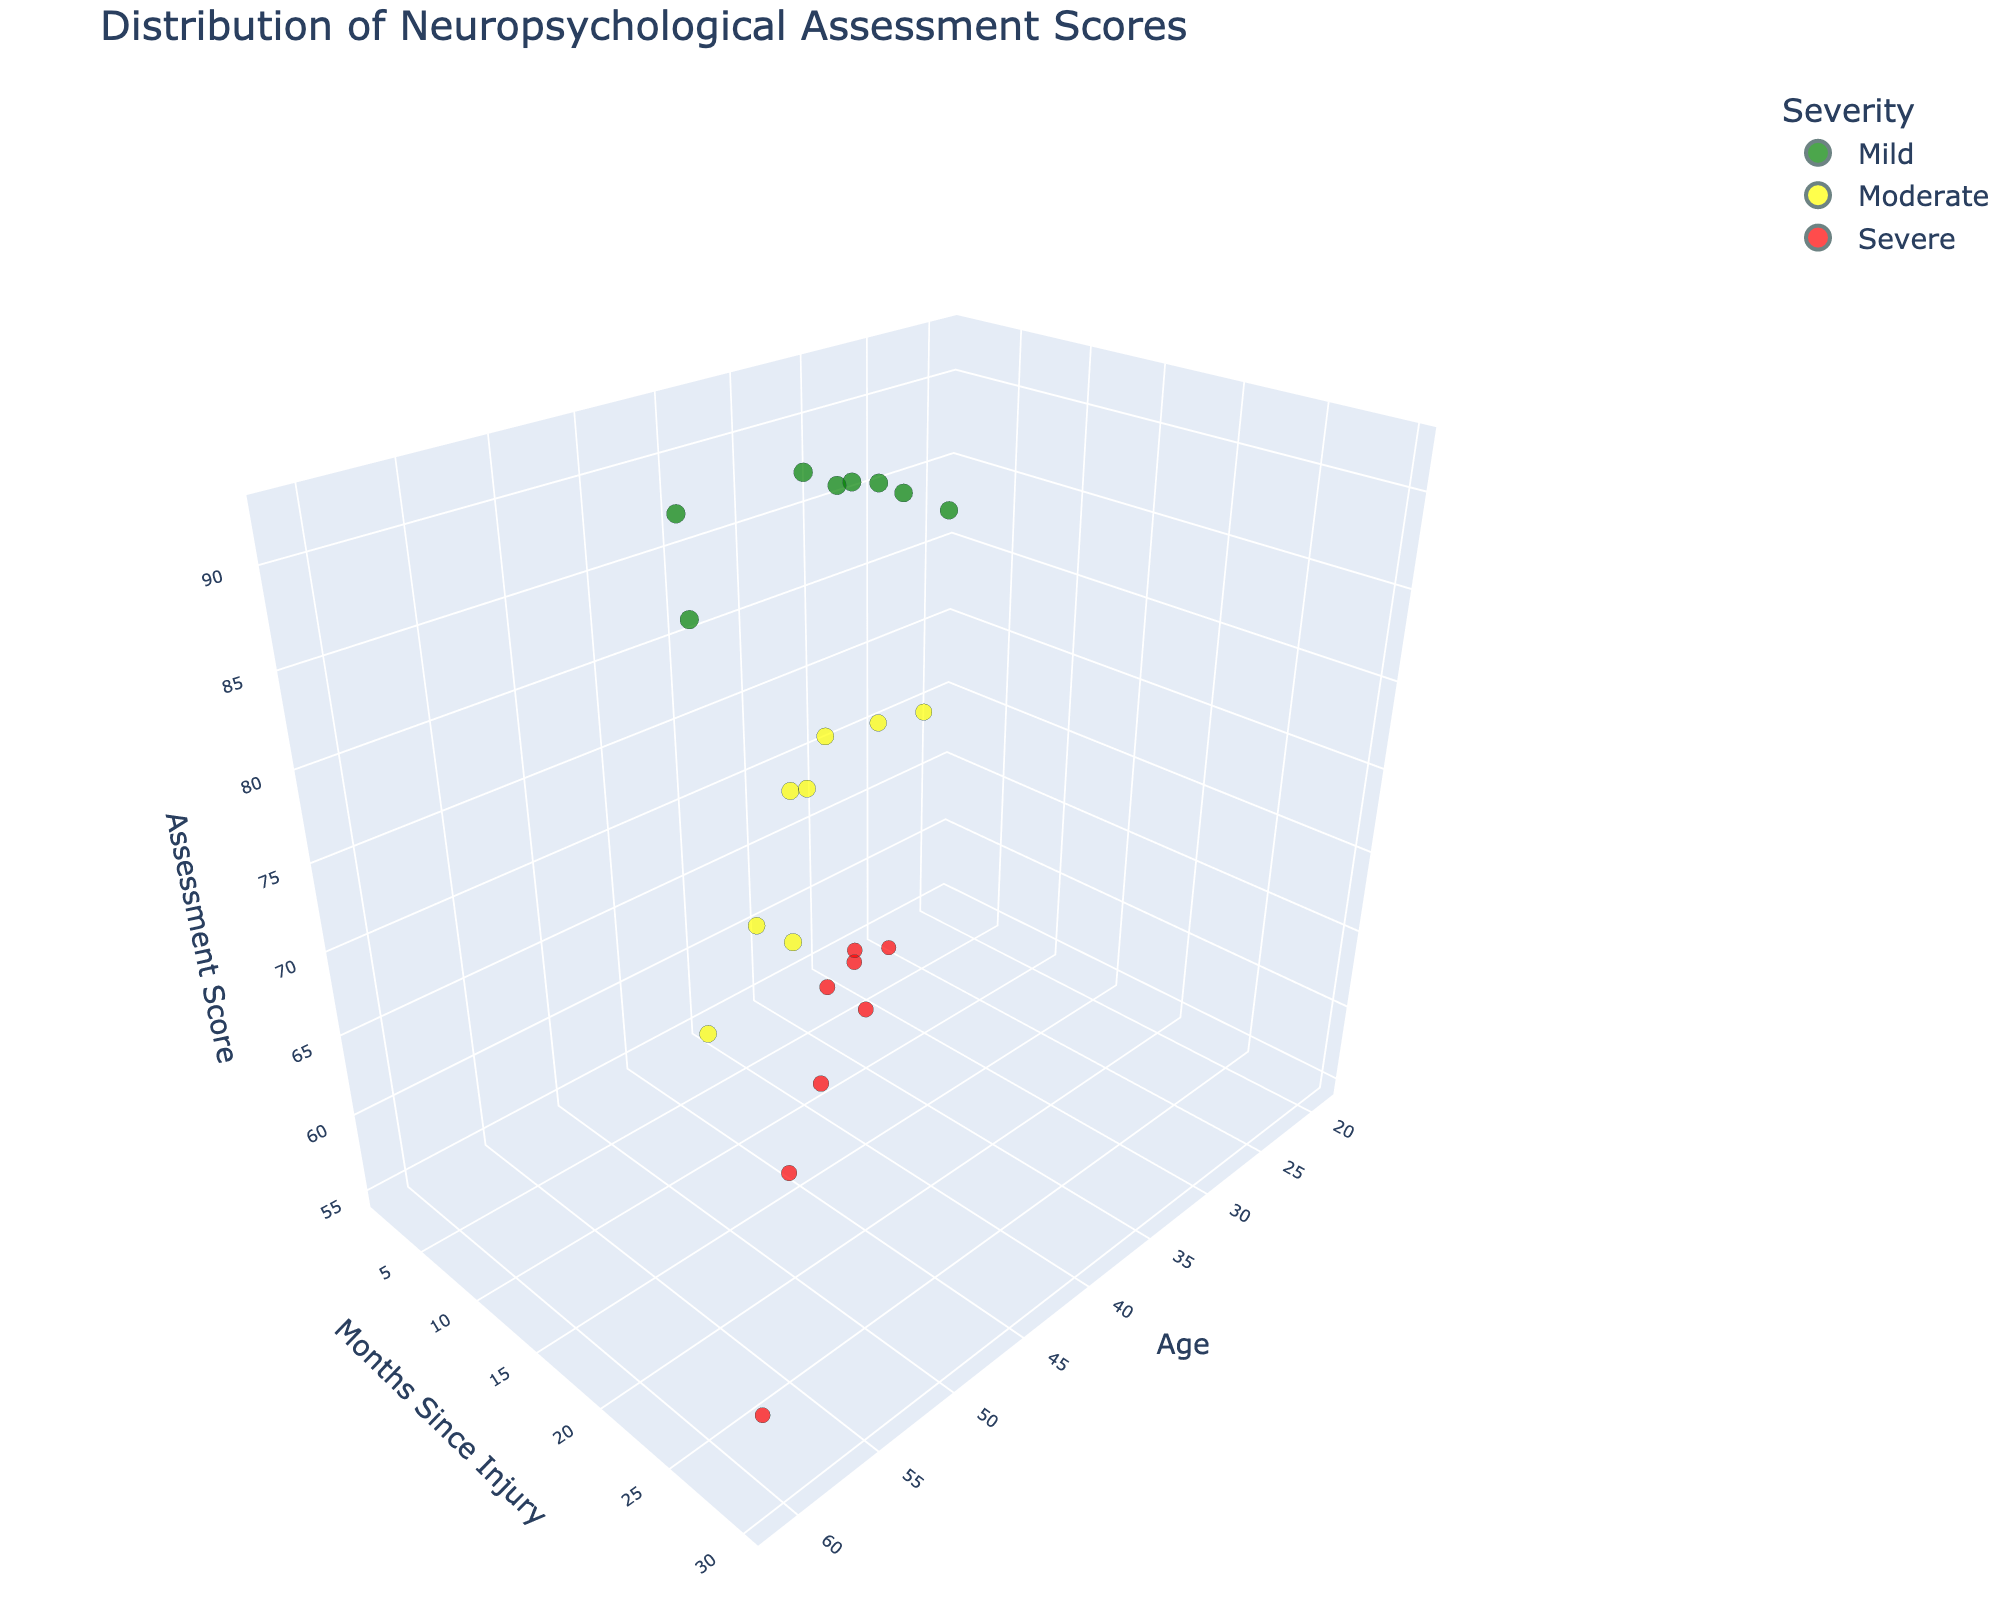What's the title of the figure? Look at the top of the figure where the title is displayed. The title provides insight into what the figure represents.
Answer: Distribution of Neuropsychological Assessment Scores What are the three axes labeled as? Look at the labels on the x-axis, y-axis, and z-axis. These labels indicate what each axis represents.
Answer: Age, Months Since Injury, Assessment Score How many data points represent patients with severe injury? Count the number of red points on the figure since 'Severe' is mapped to the color red.
Answer: 8 Which injury severity category has the highest assessment score in the figure? Find the data point with the highest z-coordinate value and note its associated color, which indicates the injury severity category.
Answer: Mild What is the average assessment score for patients aged 30 and above? Identify the points where the x-coordinate (Age) is 30 or greater, sum their z-coordinate values (Assessment Score), and divide by the number of such points. Points are: 88, 92, 90, 72, 76, 78, 75, 62, 65, 60, 59, 91, 77, 74, 63, 61. Sum = 1182, Count = 16. Average = 1182/16 = 73.88
Answer: 73.88 Comparing mild and severe injury categories, which group generally has higher assessment scores? Observe the distribution of green and red points in the z-axis. Green (Mild) points appear higher on the z-axis compared to red (Severe) points.
Answer: Mild For ages between 20 and 40, what is the maximum assessment score observed? Filter the points where the x-coordinate (Age) is between 20 and 40, and find the maximum value of z-coordinate (Assessment Score). Points 85, 88, 72, 76, 92, 70, 58, 62, 55, 87, 59, 61. The maximum score is 92.
Answer: 92 How does the assessment score vary with the months since injury for patients with a moderate injury? Observe the yellow points representing moderate injury across the y-axis (Months Since Injury). Assessment scores (z-axis) tend to be highest closer to the injury month and lower as months since injury increase.
Answer: Decreases Which age group has the most variation in assessment scores for patients with severe injuries? Examine the red points representing severe injury across the x-axis (Age) and assess the spread along the z-axis (Assessment score). Ages around 30-48 show more variation with scores from 55 to around 65-63.
Answer: 30-48 